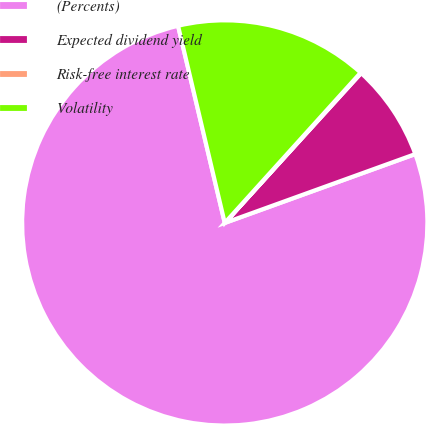<chart> <loc_0><loc_0><loc_500><loc_500><pie_chart><fcel>(Percents)<fcel>Expected dividend yield<fcel>Risk-free interest rate<fcel>Volatility<nl><fcel>76.81%<fcel>7.73%<fcel>0.05%<fcel>15.4%<nl></chart> 